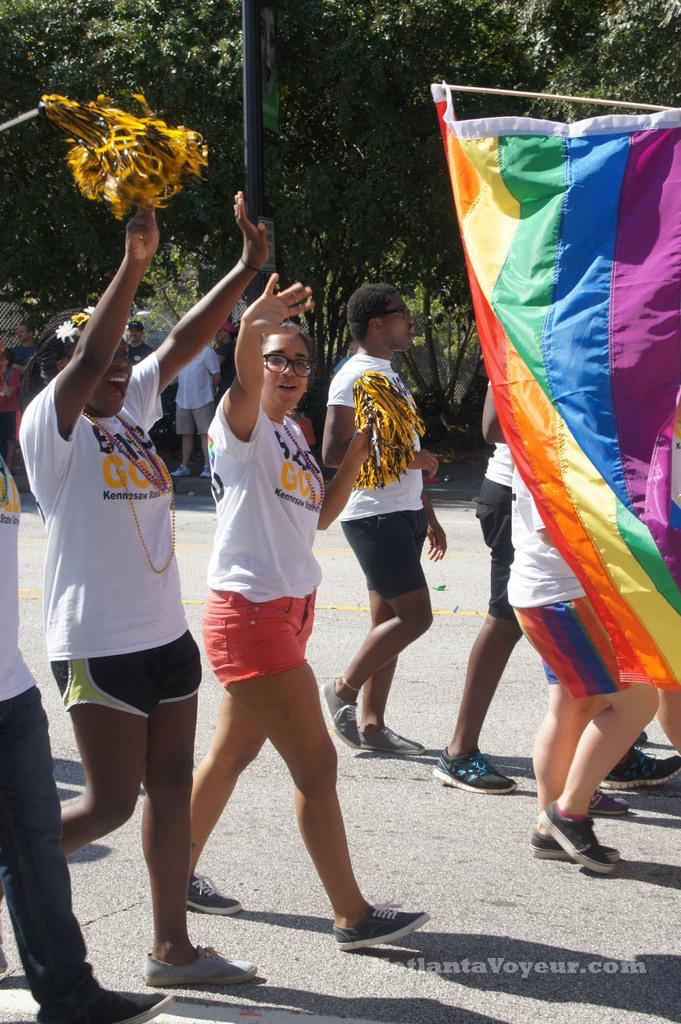What are the people in the image doing? The people in the image are walking on the road and cheering. Can you describe the flag in the image? Yes, there is a flag on the right side of the image. What can be seen in the background of the image? Trees and a pole are present in the background of the image. What type of health advice can be seen on the pole in the image? There is no health advice or any text related to health on the pole in the image. 